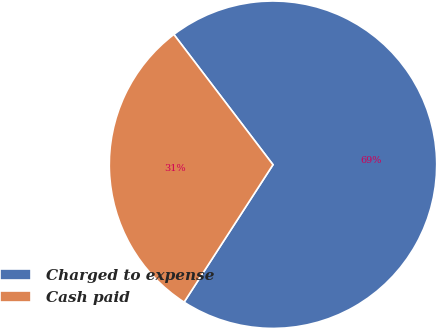Convert chart. <chart><loc_0><loc_0><loc_500><loc_500><pie_chart><fcel>Charged to expense<fcel>Cash paid<nl><fcel>69.49%<fcel>30.51%<nl></chart> 